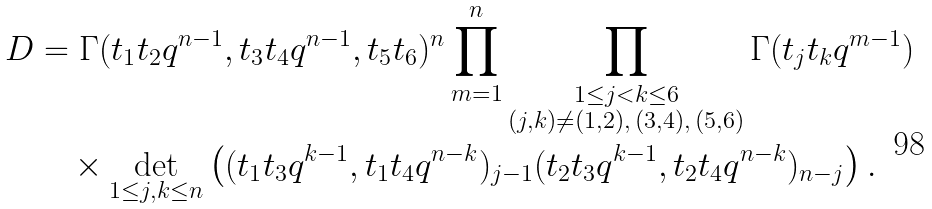<formula> <loc_0><loc_0><loc_500><loc_500>D & = \Gamma ( t _ { 1 } t _ { 2 } q ^ { n - 1 } , t _ { 3 } t _ { 4 } q ^ { n - 1 } , t _ { 5 } t _ { 6 } ) ^ { n } \prod _ { m = 1 } ^ { n } \prod _ { \substack { 1 \leq j < k \leq 6 \\ ( j , k ) \neq ( 1 , 2 ) , \, ( 3 , 4 ) , \, ( 5 , 6 ) } } \Gamma ( t _ { j } t _ { k } q ^ { m - 1 } ) \\ & \quad \times \det _ { 1 \leq j , k \leq n } \left ( ( t _ { 1 } t _ { 3 } q ^ { k - 1 } , t _ { 1 } t _ { 4 } q ^ { n - k } ) _ { j - 1 } ( t _ { 2 } t _ { 3 } q ^ { k - 1 } , t _ { 2 } t _ { 4 } q ^ { n - k } ) _ { n - j } \right ) .</formula> 